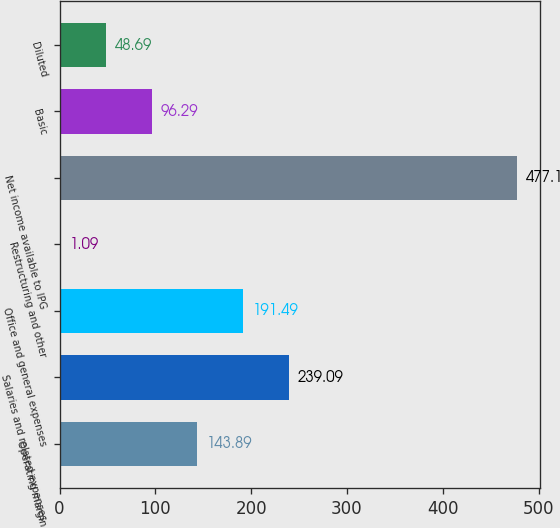Convert chart. <chart><loc_0><loc_0><loc_500><loc_500><bar_chart><fcel>Operating margin<fcel>Salaries and related expenses<fcel>Office and general expenses<fcel>Restructuring and other<fcel>Net income available to IPG<fcel>Basic<fcel>Diluted<nl><fcel>143.89<fcel>239.09<fcel>191.49<fcel>1.09<fcel>477.1<fcel>96.29<fcel>48.69<nl></chart> 